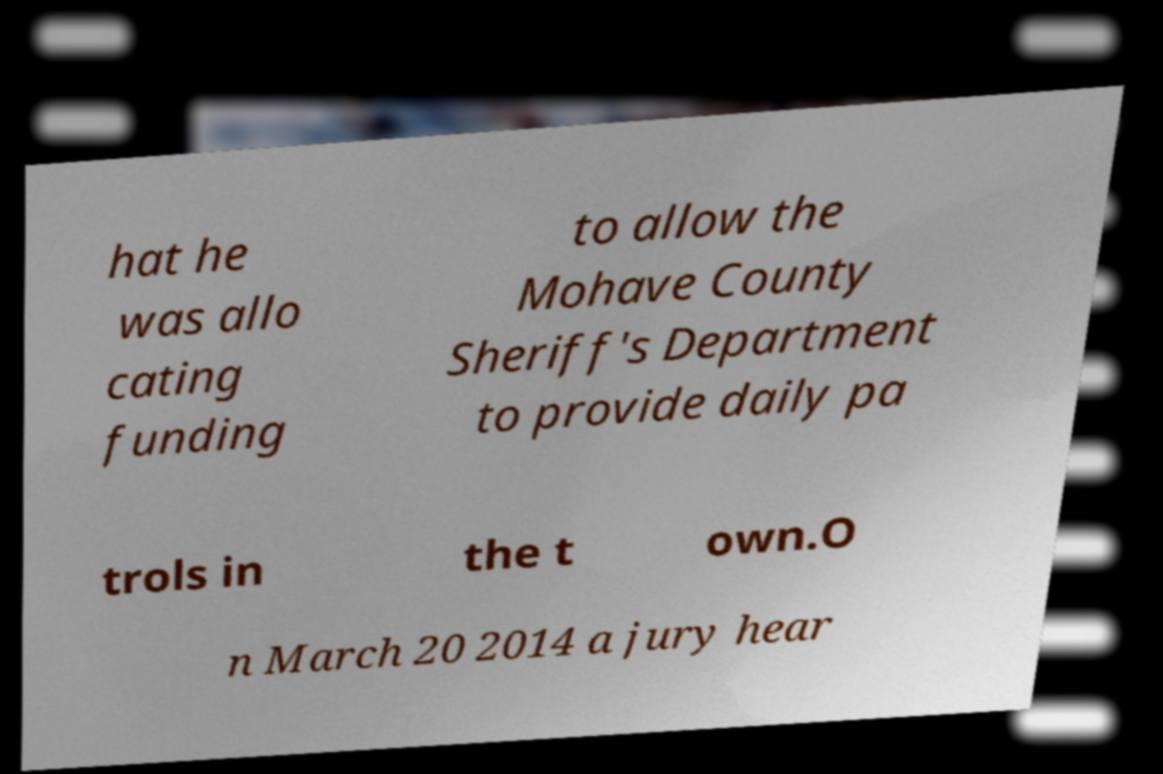Please identify and transcribe the text found in this image. hat he was allo cating funding to allow the Mohave County Sheriff's Department to provide daily pa trols in the t own.O n March 20 2014 a jury hear 